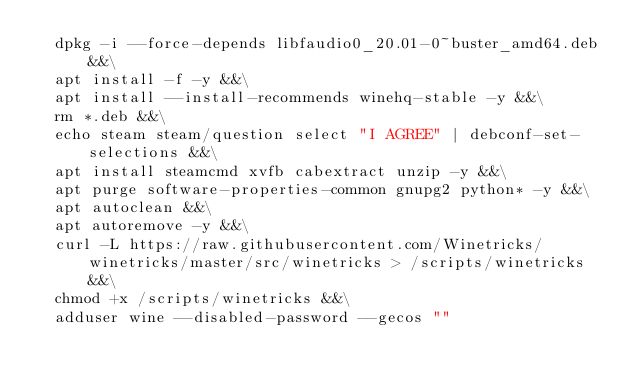Convert code to text. <code><loc_0><loc_0><loc_500><loc_500><_Dockerfile_>  dpkg -i --force-depends libfaudio0_20.01-0~buster_amd64.deb &&\
  apt install -f -y &&\
  apt install --install-recommends winehq-stable -y &&\
  rm *.deb &&\
  echo steam steam/question select "I AGREE" | debconf-set-selections &&\
  apt install steamcmd xvfb cabextract unzip -y &&\
  apt purge software-properties-common gnupg2 python* -y &&\
  apt autoclean &&\
  apt autoremove -y &&\
  curl -L https://raw.githubusercontent.com/Winetricks/winetricks/master/src/winetricks > /scripts/winetricks &&\
  chmod +x /scripts/winetricks &&\
  adduser wine --disabled-password --gecos "" </code> 